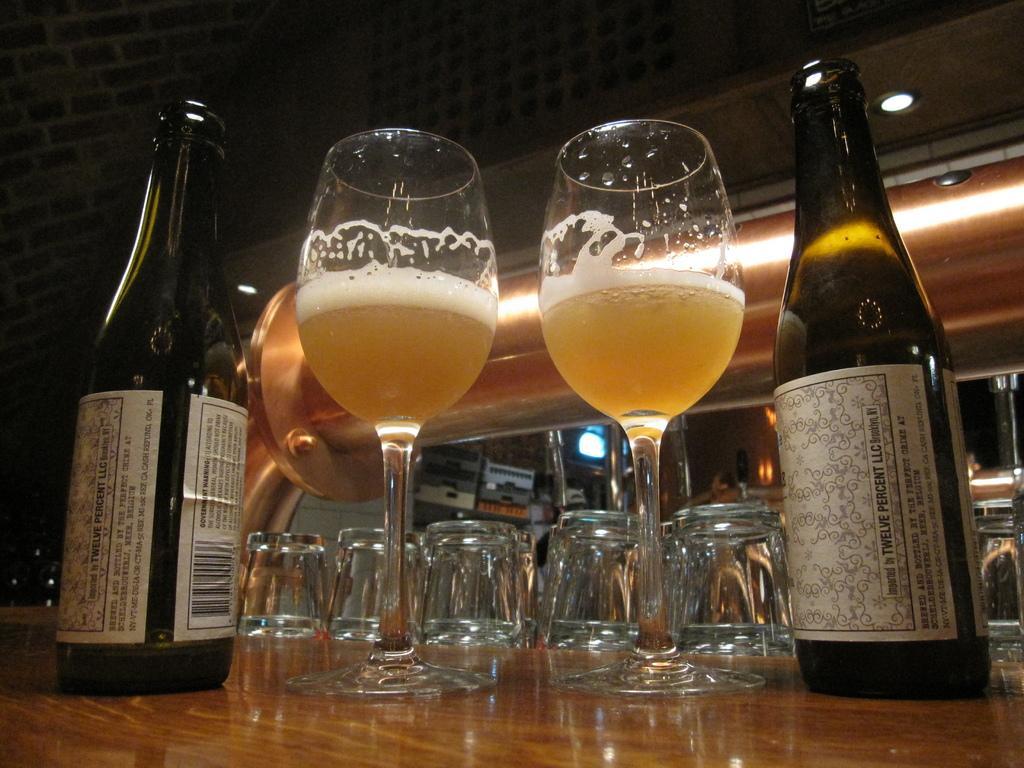In one or two sentences, can you explain what this image depicts? In the image in the center there is a table. On the table, we can see wine bottles, wine glasses and shot glasses. In the background there is a wall, roof, lights and a few other objects. 